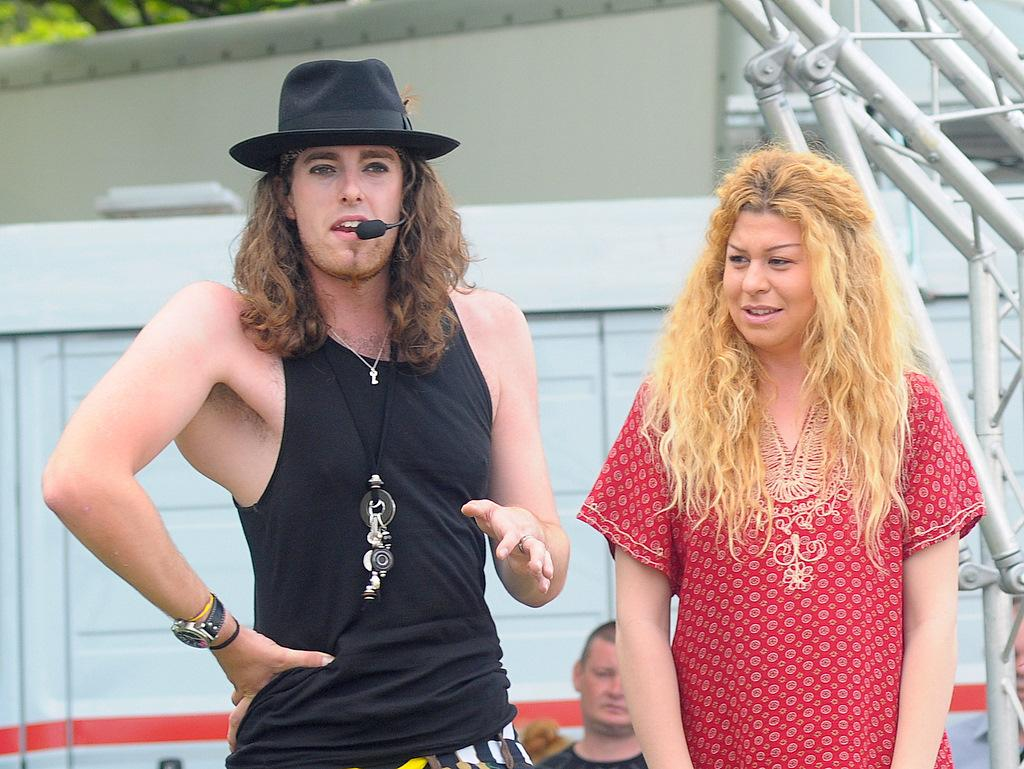How many people are in the foreground of the image? There are two people, a woman and a man, in the foreground of the image. Can you describe the third person in the image? There is another person in the image, but their description is not provided in the facts. What can be seen in the background of the image? There is: There appears to be a building structure and a tree in the background of the image. What type of beetle can be seen crawling on the man's shoulder in the image? There is no beetle present on the man's shoulder in the image. How does the government respond to the wave in the image? There is no wave or any reference to the government in the image. 